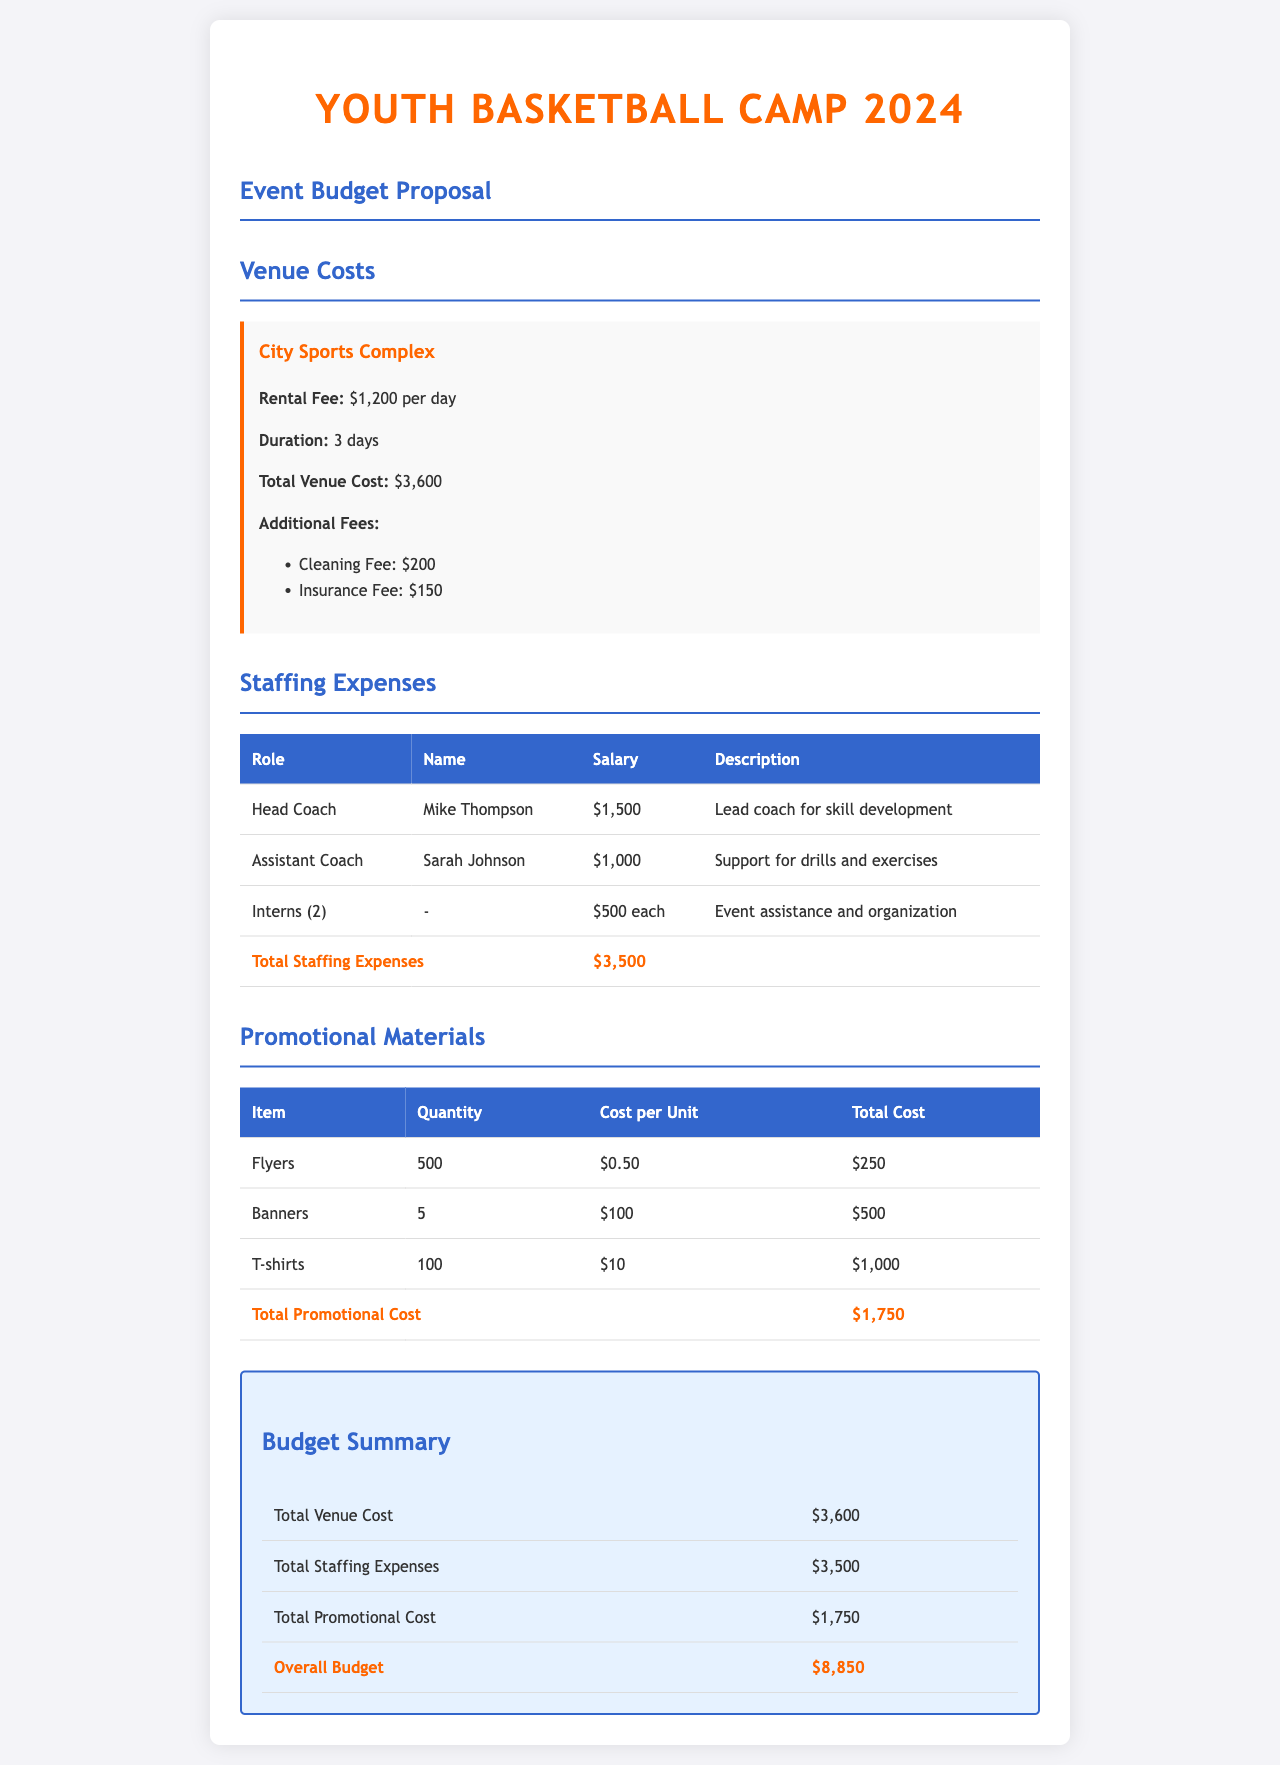What is the rental fee for the venue? The rental fee for the City Sports Complex is stated clearly in the venue costs section, which is $1,200 per day.
Answer: $1,200 per day How many days will the venue be rented? The duration for renting the City Sports Complex is specified in the venue costs section as 3 days.
Answer: 3 days What are the additional fees for the venue? The document lists the additional fees under venue costs, which include a cleaning fee of $200 and an insurance fee of $150.
Answer: Cleaning Fee: $200, Insurance Fee: $150 Who is the Head Coach? The Head Coach's name is mentioned in the staffing expenses section of the document, which is Mike Thompson.
Answer: Mike Thompson What is the total staffing expense? The total staffing expenses sum up the costs listed in the staffing expenses table, which is $3,500.
Answer: $3,500 How many T-shirts are being produced for promotional materials? The total quantity of T-shirts listed in the promotional materials table is 100.
Answer: 100 What is the total cost for promotional materials? The overall cost for promotional materials can be found in the respective table, which totals $1,750.
Answer: $1,750 What is the overall budget for the event? The overall budget is calculated from the budget summary section, which totals $8,850.
Answer: $8,850 What role does Sarah Johnson hold? The document specifies that Sarah Johnson is the Assistant Coach in the staffing expenses section.
Answer: Assistant Coach 